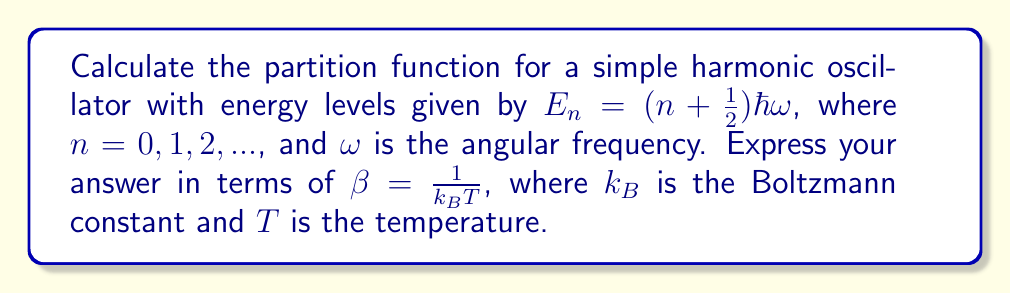Help me with this question. Let's approach this step-by-step:

1) The partition function $Z$ is defined as the sum over all possible states:

   $$Z = \sum_{n=0}^{\infty} e^{-\beta E_n}$$

2) Substituting the energy levels:

   $$Z = \sum_{n=0}^{\infty} e^{-\beta(n + \frac{1}{2})\hbar\omega}$$

3) We can factor out the constant term:

   $$Z = e^{-\beta\frac{1}{2}\hbar\omega} \sum_{n=0}^{\infty} e^{-\beta n\hbar\omega}$$

4) Let's define $x = e^{-\beta\hbar\omega}$ for simplicity. Then:

   $$Z = e^{-\beta\frac{1}{2}\hbar\omega} \sum_{n=0}^{\infty} x^n$$

5) The sum $\sum_{n=0}^{\infty} x^n$ is a geometric series with $|x| < 1$. Its sum is given by:

   $$\sum_{n=0}^{\infty} x^n = \frac{1}{1-x}$$

6) Substituting back:

   $$Z = e^{-\beta\frac{1}{2}\hbar\omega} \frac{1}{1-e^{-\beta\hbar\omega}}$$

7) This can be simplified to:

   $$Z = \frac{e^{-\beta\frac{1}{2}\hbar\omega}}{1-e^{-\beta\hbar\omega}}$$

This is the partition function for a simple harmonic oscillator.
Answer: $$Z = \frac{e^{-\beta\frac{1}{2}\hbar\omega}}{1-e^{-\beta\hbar\omega}}$$ 